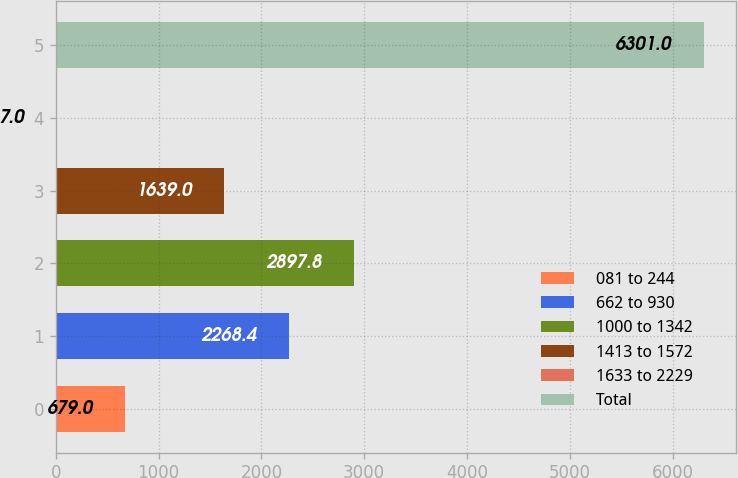<chart> <loc_0><loc_0><loc_500><loc_500><bar_chart><fcel>081 to 244<fcel>662 to 930<fcel>1000 to 1342<fcel>1413 to 1572<fcel>1633 to 2229<fcel>Total<nl><fcel>679<fcel>2268.4<fcel>2897.8<fcel>1639<fcel>7<fcel>6301<nl></chart> 